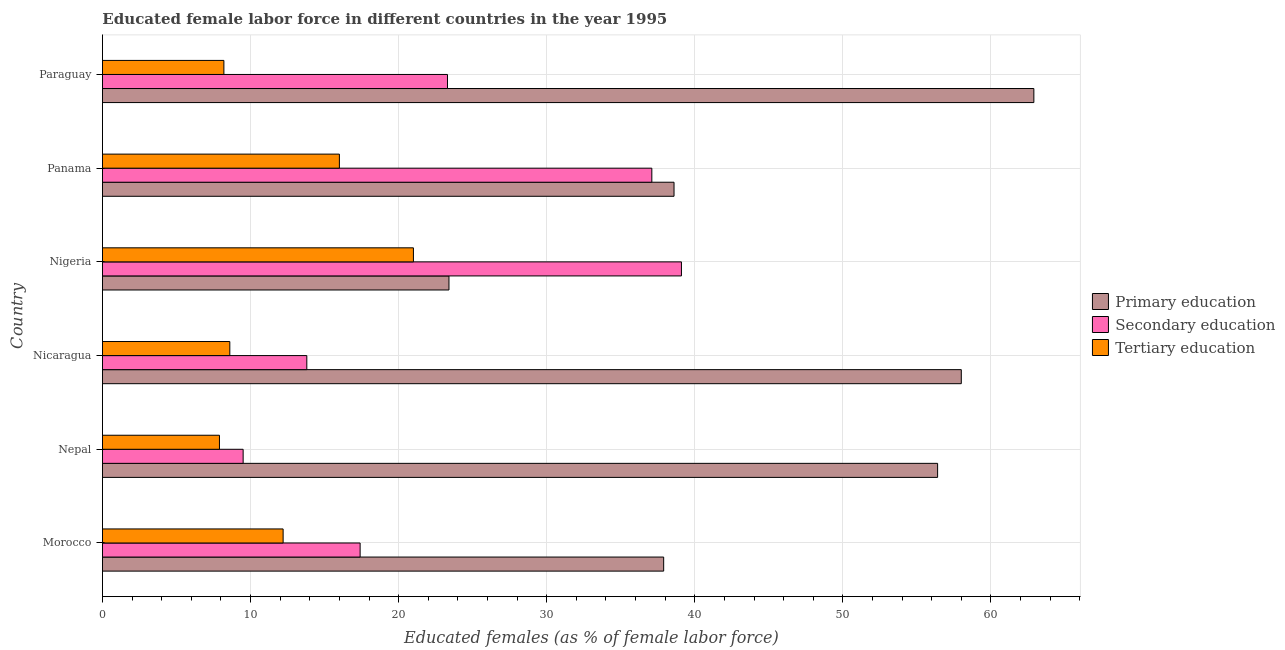How many groups of bars are there?
Keep it short and to the point. 6. Are the number of bars per tick equal to the number of legend labels?
Provide a short and direct response. Yes. Are the number of bars on each tick of the Y-axis equal?
Provide a succinct answer. Yes. How many bars are there on the 1st tick from the bottom?
Your response must be concise. 3. What is the label of the 3rd group of bars from the top?
Offer a very short reply. Nigeria. What is the percentage of female labor force who received secondary education in Panama?
Give a very brief answer. 37.1. Across all countries, what is the maximum percentage of female labor force who received tertiary education?
Offer a terse response. 21. Across all countries, what is the minimum percentage of female labor force who received tertiary education?
Your answer should be compact. 7.9. In which country was the percentage of female labor force who received tertiary education maximum?
Your answer should be compact. Nigeria. In which country was the percentage of female labor force who received tertiary education minimum?
Ensure brevity in your answer.  Nepal. What is the total percentage of female labor force who received primary education in the graph?
Your response must be concise. 277.2. What is the average percentage of female labor force who received tertiary education per country?
Provide a short and direct response. 12.32. What is the difference between the percentage of female labor force who received primary education and percentage of female labor force who received secondary education in Nigeria?
Offer a terse response. -15.7. What is the ratio of the percentage of female labor force who received secondary education in Nicaragua to that in Paraguay?
Ensure brevity in your answer.  0.59. Is the difference between the percentage of female labor force who received secondary education in Morocco and Nepal greater than the difference between the percentage of female labor force who received primary education in Morocco and Nepal?
Provide a succinct answer. Yes. What is the difference between the highest and the second highest percentage of female labor force who received secondary education?
Keep it short and to the point. 2. What is the difference between the highest and the lowest percentage of female labor force who received tertiary education?
Offer a terse response. 13.1. Is the sum of the percentage of female labor force who received primary education in Morocco and Nepal greater than the maximum percentage of female labor force who received tertiary education across all countries?
Make the answer very short. Yes. What does the 3rd bar from the bottom in Nigeria represents?
Your answer should be very brief. Tertiary education. Does the graph contain grids?
Keep it short and to the point. Yes. Where does the legend appear in the graph?
Give a very brief answer. Center right. How many legend labels are there?
Provide a succinct answer. 3. How are the legend labels stacked?
Make the answer very short. Vertical. What is the title of the graph?
Keep it short and to the point. Educated female labor force in different countries in the year 1995. Does "Ores and metals" appear as one of the legend labels in the graph?
Make the answer very short. No. What is the label or title of the X-axis?
Your answer should be very brief. Educated females (as % of female labor force). What is the label or title of the Y-axis?
Your response must be concise. Country. What is the Educated females (as % of female labor force) of Primary education in Morocco?
Offer a terse response. 37.9. What is the Educated females (as % of female labor force) of Secondary education in Morocco?
Your answer should be very brief. 17.4. What is the Educated females (as % of female labor force) in Tertiary education in Morocco?
Offer a very short reply. 12.2. What is the Educated females (as % of female labor force) in Primary education in Nepal?
Give a very brief answer. 56.4. What is the Educated females (as % of female labor force) of Tertiary education in Nepal?
Give a very brief answer. 7.9. What is the Educated females (as % of female labor force) in Primary education in Nicaragua?
Provide a short and direct response. 58. What is the Educated females (as % of female labor force) of Secondary education in Nicaragua?
Keep it short and to the point. 13.8. What is the Educated females (as % of female labor force) of Tertiary education in Nicaragua?
Your response must be concise. 8.6. What is the Educated females (as % of female labor force) in Primary education in Nigeria?
Your response must be concise. 23.4. What is the Educated females (as % of female labor force) of Secondary education in Nigeria?
Give a very brief answer. 39.1. What is the Educated females (as % of female labor force) of Primary education in Panama?
Keep it short and to the point. 38.6. What is the Educated females (as % of female labor force) in Secondary education in Panama?
Offer a very short reply. 37.1. What is the Educated females (as % of female labor force) of Primary education in Paraguay?
Give a very brief answer. 62.9. What is the Educated females (as % of female labor force) in Secondary education in Paraguay?
Your answer should be compact. 23.3. What is the Educated females (as % of female labor force) of Tertiary education in Paraguay?
Give a very brief answer. 8.2. Across all countries, what is the maximum Educated females (as % of female labor force) in Primary education?
Ensure brevity in your answer.  62.9. Across all countries, what is the maximum Educated females (as % of female labor force) of Secondary education?
Your response must be concise. 39.1. Across all countries, what is the minimum Educated females (as % of female labor force) in Primary education?
Provide a short and direct response. 23.4. Across all countries, what is the minimum Educated females (as % of female labor force) in Tertiary education?
Your answer should be compact. 7.9. What is the total Educated females (as % of female labor force) of Primary education in the graph?
Provide a succinct answer. 277.2. What is the total Educated females (as % of female labor force) in Secondary education in the graph?
Your response must be concise. 140.2. What is the total Educated females (as % of female labor force) in Tertiary education in the graph?
Offer a very short reply. 73.9. What is the difference between the Educated females (as % of female labor force) of Primary education in Morocco and that in Nepal?
Give a very brief answer. -18.5. What is the difference between the Educated females (as % of female labor force) of Primary education in Morocco and that in Nicaragua?
Ensure brevity in your answer.  -20.1. What is the difference between the Educated females (as % of female labor force) of Tertiary education in Morocco and that in Nicaragua?
Your answer should be very brief. 3.6. What is the difference between the Educated females (as % of female labor force) of Secondary education in Morocco and that in Nigeria?
Keep it short and to the point. -21.7. What is the difference between the Educated females (as % of female labor force) of Tertiary education in Morocco and that in Nigeria?
Offer a very short reply. -8.8. What is the difference between the Educated females (as % of female labor force) in Secondary education in Morocco and that in Panama?
Your response must be concise. -19.7. What is the difference between the Educated females (as % of female labor force) in Tertiary education in Morocco and that in Panama?
Make the answer very short. -3.8. What is the difference between the Educated females (as % of female labor force) in Primary education in Morocco and that in Paraguay?
Your answer should be compact. -25. What is the difference between the Educated females (as % of female labor force) of Secondary education in Morocco and that in Paraguay?
Keep it short and to the point. -5.9. What is the difference between the Educated females (as % of female labor force) in Tertiary education in Morocco and that in Paraguay?
Give a very brief answer. 4. What is the difference between the Educated females (as % of female labor force) in Tertiary education in Nepal and that in Nicaragua?
Provide a short and direct response. -0.7. What is the difference between the Educated females (as % of female labor force) in Primary education in Nepal and that in Nigeria?
Keep it short and to the point. 33. What is the difference between the Educated females (as % of female labor force) in Secondary education in Nepal and that in Nigeria?
Your answer should be very brief. -29.6. What is the difference between the Educated females (as % of female labor force) of Primary education in Nepal and that in Panama?
Your answer should be very brief. 17.8. What is the difference between the Educated females (as % of female labor force) in Secondary education in Nepal and that in Panama?
Your answer should be very brief. -27.6. What is the difference between the Educated females (as % of female labor force) in Tertiary education in Nepal and that in Panama?
Give a very brief answer. -8.1. What is the difference between the Educated females (as % of female labor force) in Primary education in Nicaragua and that in Nigeria?
Provide a succinct answer. 34.6. What is the difference between the Educated females (as % of female labor force) of Secondary education in Nicaragua and that in Nigeria?
Offer a very short reply. -25.3. What is the difference between the Educated females (as % of female labor force) in Primary education in Nicaragua and that in Panama?
Your answer should be very brief. 19.4. What is the difference between the Educated females (as % of female labor force) of Secondary education in Nicaragua and that in Panama?
Make the answer very short. -23.3. What is the difference between the Educated females (as % of female labor force) of Tertiary education in Nicaragua and that in Panama?
Give a very brief answer. -7.4. What is the difference between the Educated females (as % of female labor force) of Secondary education in Nicaragua and that in Paraguay?
Your answer should be compact. -9.5. What is the difference between the Educated females (as % of female labor force) of Tertiary education in Nicaragua and that in Paraguay?
Make the answer very short. 0.4. What is the difference between the Educated females (as % of female labor force) in Primary education in Nigeria and that in Panama?
Keep it short and to the point. -15.2. What is the difference between the Educated females (as % of female labor force) of Primary education in Nigeria and that in Paraguay?
Offer a terse response. -39.5. What is the difference between the Educated females (as % of female labor force) of Tertiary education in Nigeria and that in Paraguay?
Your response must be concise. 12.8. What is the difference between the Educated females (as % of female labor force) in Primary education in Panama and that in Paraguay?
Provide a succinct answer. -24.3. What is the difference between the Educated females (as % of female labor force) in Primary education in Morocco and the Educated females (as % of female labor force) in Secondary education in Nepal?
Offer a terse response. 28.4. What is the difference between the Educated females (as % of female labor force) of Primary education in Morocco and the Educated females (as % of female labor force) of Tertiary education in Nepal?
Provide a short and direct response. 30. What is the difference between the Educated females (as % of female labor force) in Secondary education in Morocco and the Educated females (as % of female labor force) in Tertiary education in Nepal?
Give a very brief answer. 9.5. What is the difference between the Educated females (as % of female labor force) of Primary education in Morocco and the Educated females (as % of female labor force) of Secondary education in Nicaragua?
Your answer should be compact. 24.1. What is the difference between the Educated females (as % of female labor force) of Primary education in Morocco and the Educated females (as % of female labor force) of Tertiary education in Nicaragua?
Make the answer very short. 29.3. What is the difference between the Educated females (as % of female labor force) of Secondary education in Morocco and the Educated females (as % of female labor force) of Tertiary education in Nicaragua?
Your response must be concise. 8.8. What is the difference between the Educated females (as % of female labor force) of Primary education in Morocco and the Educated females (as % of female labor force) of Secondary education in Nigeria?
Your response must be concise. -1.2. What is the difference between the Educated females (as % of female labor force) in Primary education in Morocco and the Educated females (as % of female labor force) in Secondary education in Panama?
Provide a short and direct response. 0.8. What is the difference between the Educated females (as % of female labor force) of Primary education in Morocco and the Educated females (as % of female labor force) of Tertiary education in Panama?
Offer a terse response. 21.9. What is the difference between the Educated females (as % of female labor force) in Primary education in Morocco and the Educated females (as % of female labor force) in Secondary education in Paraguay?
Give a very brief answer. 14.6. What is the difference between the Educated females (as % of female labor force) of Primary education in Morocco and the Educated females (as % of female labor force) of Tertiary education in Paraguay?
Make the answer very short. 29.7. What is the difference between the Educated females (as % of female labor force) in Primary education in Nepal and the Educated females (as % of female labor force) in Secondary education in Nicaragua?
Make the answer very short. 42.6. What is the difference between the Educated females (as % of female labor force) of Primary education in Nepal and the Educated females (as % of female labor force) of Tertiary education in Nicaragua?
Offer a terse response. 47.8. What is the difference between the Educated females (as % of female labor force) in Secondary education in Nepal and the Educated females (as % of female labor force) in Tertiary education in Nicaragua?
Ensure brevity in your answer.  0.9. What is the difference between the Educated females (as % of female labor force) in Primary education in Nepal and the Educated females (as % of female labor force) in Tertiary education in Nigeria?
Make the answer very short. 35.4. What is the difference between the Educated females (as % of female labor force) in Primary education in Nepal and the Educated females (as % of female labor force) in Secondary education in Panama?
Keep it short and to the point. 19.3. What is the difference between the Educated females (as % of female labor force) in Primary education in Nepal and the Educated females (as % of female labor force) in Tertiary education in Panama?
Your response must be concise. 40.4. What is the difference between the Educated females (as % of female labor force) of Primary education in Nepal and the Educated females (as % of female labor force) of Secondary education in Paraguay?
Your answer should be compact. 33.1. What is the difference between the Educated females (as % of female labor force) in Primary education in Nepal and the Educated females (as % of female labor force) in Tertiary education in Paraguay?
Offer a terse response. 48.2. What is the difference between the Educated females (as % of female labor force) in Primary education in Nicaragua and the Educated females (as % of female labor force) in Tertiary education in Nigeria?
Your answer should be compact. 37. What is the difference between the Educated females (as % of female labor force) of Primary education in Nicaragua and the Educated females (as % of female labor force) of Secondary education in Panama?
Give a very brief answer. 20.9. What is the difference between the Educated females (as % of female labor force) in Primary education in Nicaragua and the Educated females (as % of female labor force) in Tertiary education in Panama?
Give a very brief answer. 42. What is the difference between the Educated females (as % of female labor force) of Primary education in Nicaragua and the Educated females (as % of female labor force) of Secondary education in Paraguay?
Your response must be concise. 34.7. What is the difference between the Educated females (as % of female labor force) in Primary education in Nicaragua and the Educated females (as % of female labor force) in Tertiary education in Paraguay?
Give a very brief answer. 49.8. What is the difference between the Educated females (as % of female labor force) of Secondary education in Nicaragua and the Educated females (as % of female labor force) of Tertiary education in Paraguay?
Keep it short and to the point. 5.6. What is the difference between the Educated females (as % of female labor force) of Primary education in Nigeria and the Educated females (as % of female labor force) of Secondary education in Panama?
Provide a short and direct response. -13.7. What is the difference between the Educated females (as % of female labor force) in Secondary education in Nigeria and the Educated females (as % of female labor force) in Tertiary education in Panama?
Ensure brevity in your answer.  23.1. What is the difference between the Educated females (as % of female labor force) in Primary education in Nigeria and the Educated females (as % of female labor force) in Tertiary education in Paraguay?
Keep it short and to the point. 15.2. What is the difference between the Educated females (as % of female labor force) in Secondary education in Nigeria and the Educated females (as % of female labor force) in Tertiary education in Paraguay?
Keep it short and to the point. 30.9. What is the difference between the Educated females (as % of female labor force) of Primary education in Panama and the Educated females (as % of female labor force) of Secondary education in Paraguay?
Your response must be concise. 15.3. What is the difference between the Educated females (as % of female labor force) in Primary education in Panama and the Educated females (as % of female labor force) in Tertiary education in Paraguay?
Keep it short and to the point. 30.4. What is the difference between the Educated females (as % of female labor force) of Secondary education in Panama and the Educated females (as % of female labor force) of Tertiary education in Paraguay?
Ensure brevity in your answer.  28.9. What is the average Educated females (as % of female labor force) in Primary education per country?
Provide a succinct answer. 46.2. What is the average Educated females (as % of female labor force) of Secondary education per country?
Offer a terse response. 23.37. What is the average Educated females (as % of female labor force) in Tertiary education per country?
Your answer should be compact. 12.32. What is the difference between the Educated females (as % of female labor force) of Primary education and Educated females (as % of female labor force) of Tertiary education in Morocco?
Your answer should be compact. 25.7. What is the difference between the Educated females (as % of female labor force) of Primary education and Educated females (as % of female labor force) of Secondary education in Nepal?
Your answer should be compact. 46.9. What is the difference between the Educated females (as % of female labor force) in Primary education and Educated females (as % of female labor force) in Tertiary education in Nepal?
Give a very brief answer. 48.5. What is the difference between the Educated females (as % of female labor force) of Primary education and Educated females (as % of female labor force) of Secondary education in Nicaragua?
Keep it short and to the point. 44.2. What is the difference between the Educated females (as % of female labor force) of Primary education and Educated females (as % of female labor force) of Tertiary education in Nicaragua?
Provide a short and direct response. 49.4. What is the difference between the Educated females (as % of female labor force) in Secondary education and Educated females (as % of female labor force) in Tertiary education in Nicaragua?
Give a very brief answer. 5.2. What is the difference between the Educated females (as % of female labor force) in Primary education and Educated females (as % of female labor force) in Secondary education in Nigeria?
Give a very brief answer. -15.7. What is the difference between the Educated females (as % of female labor force) in Primary education and Educated females (as % of female labor force) in Tertiary education in Nigeria?
Keep it short and to the point. 2.4. What is the difference between the Educated females (as % of female labor force) of Secondary education and Educated females (as % of female labor force) of Tertiary education in Nigeria?
Offer a terse response. 18.1. What is the difference between the Educated females (as % of female labor force) in Primary education and Educated females (as % of female labor force) in Secondary education in Panama?
Make the answer very short. 1.5. What is the difference between the Educated females (as % of female labor force) in Primary education and Educated females (as % of female labor force) in Tertiary education in Panama?
Offer a terse response. 22.6. What is the difference between the Educated females (as % of female labor force) of Secondary education and Educated females (as % of female labor force) of Tertiary education in Panama?
Keep it short and to the point. 21.1. What is the difference between the Educated females (as % of female labor force) in Primary education and Educated females (as % of female labor force) in Secondary education in Paraguay?
Offer a terse response. 39.6. What is the difference between the Educated females (as % of female labor force) of Primary education and Educated females (as % of female labor force) of Tertiary education in Paraguay?
Your answer should be compact. 54.7. What is the ratio of the Educated females (as % of female labor force) of Primary education in Morocco to that in Nepal?
Your answer should be compact. 0.67. What is the ratio of the Educated females (as % of female labor force) of Secondary education in Morocco to that in Nepal?
Make the answer very short. 1.83. What is the ratio of the Educated females (as % of female labor force) of Tertiary education in Morocco to that in Nepal?
Make the answer very short. 1.54. What is the ratio of the Educated females (as % of female labor force) in Primary education in Morocco to that in Nicaragua?
Make the answer very short. 0.65. What is the ratio of the Educated females (as % of female labor force) in Secondary education in Morocco to that in Nicaragua?
Offer a terse response. 1.26. What is the ratio of the Educated females (as % of female labor force) of Tertiary education in Morocco to that in Nicaragua?
Offer a very short reply. 1.42. What is the ratio of the Educated females (as % of female labor force) in Primary education in Morocco to that in Nigeria?
Give a very brief answer. 1.62. What is the ratio of the Educated females (as % of female labor force) in Secondary education in Morocco to that in Nigeria?
Provide a succinct answer. 0.45. What is the ratio of the Educated females (as % of female labor force) of Tertiary education in Morocco to that in Nigeria?
Your response must be concise. 0.58. What is the ratio of the Educated females (as % of female labor force) in Primary education in Morocco to that in Panama?
Your response must be concise. 0.98. What is the ratio of the Educated females (as % of female labor force) of Secondary education in Morocco to that in Panama?
Offer a very short reply. 0.47. What is the ratio of the Educated females (as % of female labor force) of Tertiary education in Morocco to that in Panama?
Give a very brief answer. 0.76. What is the ratio of the Educated females (as % of female labor force) of Primary education in Morocco to that in Paraguay?
Provide a succinct answer. 0.6. What is the ratio of the Educated females (as % of female labor force) in Secondary education in Morocco to that in Paraguay?
Make the answer very short. 0.75. What is the ratio of the Educated females (as % of female labor force) in Tertiary education in Morocco to that in Paraguay?
Provide a short and direct response. 1.49. What is the ratio of the Educated females (as % of female labor force) of Primary education in Nepal to that in Nicaragua?
Your answer should be very brief. 0.97. What is the ratio of the Educated females (as % of female labor force) of Secondary education in Nepal to that in Nicaragua?
Make the answer very short. 0.69. What is the ratio of the Educated females (as % of female labor force) of Tertiary education in Nepal to that in Nicaragua?
Keep it short and to the point. 0.92. What is the ratio of the Educated females (as % of female labor force) in Primary education in Nepal to that in Nigeria?
Offer a terse response. 2.41. What is the ratio of the Educated females (as % of female labor force) in Secondary education in Nepal to that in Nigeria?
Offer a terse response. 0.24. What is the ratio of the Educated females (as % of female labor force) of Tertiary education in Nepal to that in Nigeria?
Make the answer very short. 0.38. What is the ratio of the Educated females (as % of female labor force) in Primary education in Nepal to that in Panama?
Your response must be concise. 1.46. What is the ratio of the Educated females (as % of female labor force) in Secondary education in Nepal to that in Panama?
Make the answer very short. 0.26. What is the ratio of the Educated females (as % of female labor force) in Tertiary education in Nepal to that in Panama?
Make the answer very short. 0.49. What is the ratio of the Educated females (as % of female labor force) in Primary education in Nepal to that in Paraguay?
Provide a succinct answer. 0.9. What is the ratio of the Educated females (as % of female labor force) in Secondary education in Nepal to that in Paraguay?
Offer a very short reply. 0.41. What is the ratio of the Educated females (as % of female labor force) in Tertiary education in Nepal to that in Paraguay?
Offer a terse response. 0.96. What is the ratio of the Educated females (as % of female labor force) in Primary education in Nicaragua to that in Nigeria?
Ensure brevity in your answer.  2.48. What is the ratio of the Educated females (as % of female labor force) of Secondary education in Nicaragua to that in Nigeria?
Provide a succinct answer. 0.35. What is the ratio of the Educated females (as % of female labor force) of Tertiary education in Nicaragua to that in Nigeria?
Your response must be concise. 0.41. What is the ratio of the Educated females (as % of female labor force) in Primary education in Nicaragua to that in Panama?
Your answer should be compact. 1.5. What is the ratio of the Educated females (as % of female labor force) in Secondary education in Nicaragua to that in Panama?
Keep it short and to the point. 0.37. What is the ratio of the Educated females (as % of female labor force) of Tertiary education in Nicaragua to that in Panama?
Your response must be concise. 0.54. What is the ratio of the Educated females (as % of female labor force) of Primary education in Nicaragua to that in Paraguay?
Ensure brevity in your answer.  0.92. What is the ratio of the Educated females (as % of female labor force) in Secondary education in Nicaragua to that in Paraguay?
Make the answer very short. 0.59. What is the ratio of the Educated females (as % of female labor force) of Tertiary education in Nicaragua to that in Paraguay?
Provide a succinct answer. 1.05. What is the ratio of the Educated females (as % of female labor force) in Primary education in Nigeria to that in Panama?
Give a very brief answer. 0.61. What is the ratio of the Educated females (as % of female labor force) of Secondary education in Nigeria to that in Panama?
Offer a very short reply. 1.05. What is the ratio of the Educated females (as % of female labor force) in Tertiary education in Nigeria to that in Panama?
Make the answer very short. 1.31. What is the ratio of the Educated females (as % of female labor force) of Primary education in Nigeria to that in Paraguay?
Offer a terse response. 0.37. What is the ratio of the Educated females (as % of female labor force) of Secondary education in Nigeria to that in Paraguay?
Your answer should be compact. 1.68. What is the ratio of the Educated females (as % of female labor force) in Tertiary education in Nigeria to that in Paraguay?
Offer a terse response. 2.56. What is the ratio of the Educated females (as % of female labor force) of Primary education in Panama to that in Paraguay?
Offer a terse response. 0.61. What is the ratio of the Educated females (as % of female labor force) in Secondary education in Panama to that in Paraguay?
Keep it short and to the point. 1.59. What is the ratio of the Educated females (as % of female labor force) in Tertiary education in Panama to that in Paraguay?
Your answer should be very brief. 1.95. What is the difference between the highest and the second highest Educated females (as % of female labor force) of Primary education?
Your response must be concise. 4.9. What is the difference between the highest and the lowest Educated females (as % of female labor force) in Primary education?
Ensure brevity in your answer.  39.5. What is the difference between the highest and the lowest Educated females (as % of female labor force) of Secondary education?
Provide a succinct answer. 29.6. 